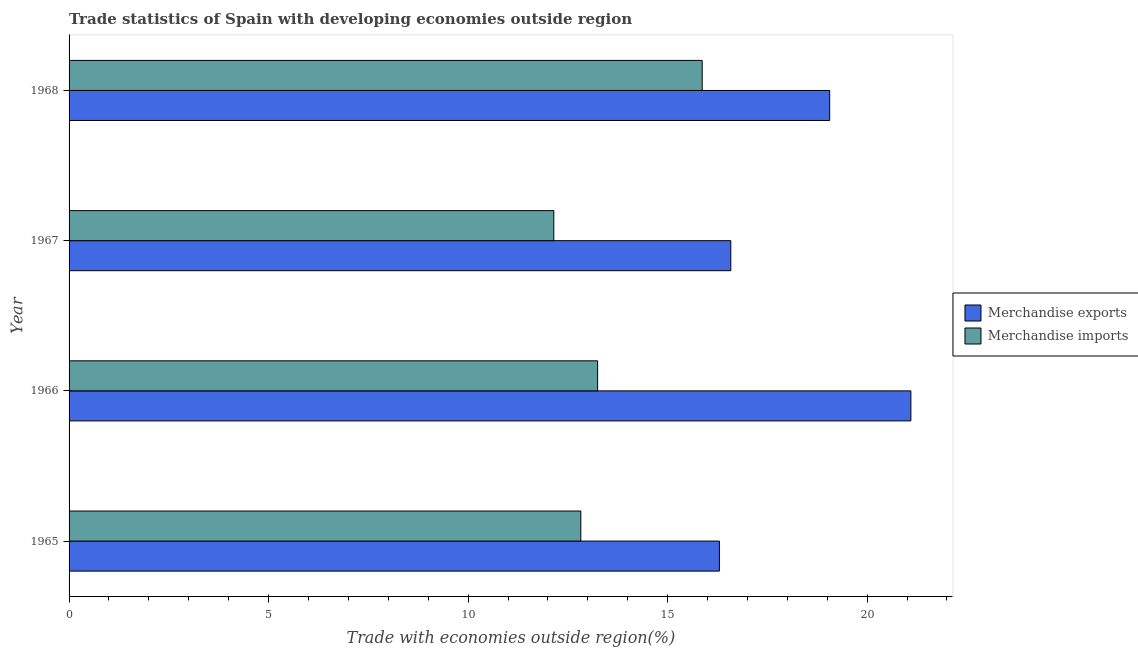How many different coloured bars are there?
Offer a very short reply. 2. How many groups of bars are there?
Give a very brief answer. 4. Are the number of bars per tick equal to the number of legend labels?
Your answer should be compact. Yes. What is the label of the 1st group of bars from the top?
Offer a terse response. 1968. What is the merchandise imports in 1967?
Provide a succinct answer. 12.15. Across all years, what is the maximum merchandise exports?
Your answer should be very brief. 21.09. Across all years, what is the minimum merchandise imports?
Give a very brief answer. 12.15. In which year was the merchandise imports maximum?
Offer a terse response. 1968. In which year was the merchandise exports minimum?
Your response must be concise. 1965. What is the total merchandise imports in the graph?
Offer a very short reply. 54.08. What is the difference between the merchandise imports in 1965 and that in 1967?
Offer a very short reply. 0.68. What is the difference between the merchandise exports in 1968 and the merchandise imports in 1965?
Provide a succinct answer. 6.24. What is the average merchandise imports per year?
Your answer should be compact. 13.52. In the year 1967, what is the difference between the merchandise imports and merchandise exports?
Your response must be concise. -4.43. What is the ratio of the merchandise imports in 1966 to that in 1967?
Provide a succinct answer. 1.09. Is the merchandise imports in 1966 less than that in 1967?
Offer a terse response. No. What is the difference between the highest and the second highest merchandise imports?
Keep it short and to the point. 2.62. What is the difference between the highest and the lowest merchandise exports?
Give a very brief answer. 4.8. In how many years, is the merchandise exports greater than the average merchandise exports taken over all years?
Your answer should be compact. 2. Is the sum of the merchandise imports in 1965 and 1966 greater than the maximum merchandise exports across all years?
Provide a short and direct response. Yes. How many bars are there?
Offer a terse response. 8. Are all the bars in the graph horizontal?
Provide a succinct answer. Yes. How many years are there in the graph?
Keep it short and to the point. 4. What is the difference between two consecutive major ticks on the X-axis?
Your answer should be compact. 5. Are the values on the major ticks of X-axis written in scientific E-notation?
Your answer should be very brief. No. Does the graph contain any zero values?
Offer a very short reply. No. Where does the legend appear in the graph?
Make the answer very short. Center right. How are the legend labels stacked?
Ensure brevity in your answer.  Vertical. What is the title of the graph?
Your response must be concise. Trade statistics of Spain with developing economies outside region. Does "Long-term debt" appear as one of the legend labels in the graph?
Your response must be concise. No. What is the label or title of the X-axis?
Provide a succinct answer. Trade with economies outside region(%). What is the label or title of the Y-axis?
Your answer should be compact. Year. What is the Trade with economies outside region(%) in Merchandise exports in 1965?
Offer a very short reply. 16.3. What is the Trade with economies outside region(%) of Merchandise imports in 1965?
Your answer should be very brief. 12.82. What is the Trade with economies outside region(%) in Merchandise exports in 1966?
Make the answer very short. 21.09. What is the Trade with economies outside region(%) of Merchandise imports in 1966?
Offer a very short reply. 13.25. What is the Trade with economies outside region(%) in Merchandise exports in 1967?
Make the answer very short. 16.58. What is the Trade with economies outside region(%) of Merchandise imports in 1967?
Your answer should be very brief. 12.15. What is the Trade with economies outside region(%) in Merchandise exports in 1968?
Your answer should be compact. 19.06. What is the Trade with economies outside region(%) in Merchandise imports in 1968?
Keep it short and to the point. 15.87. Across all years, what is the maximum Trade with economies outside region(%) of Merchandise exports?
Keep it short and to the point. 21.09. Across all years, what is the maximum Trade with economies outside region(%) of Merchandise imports?
Give a very brief answer. 15.87. Across all years, what is the minimum Trade with economies outside region(%) in Merchandise exports?
Your response must be concise. 16.3. Across all years, what is the minimum Trade with economies outside region(%) of Merchandise imports?
Ensure brevity in your answer.  12.15. What is the total Trade with economies outside region(%) in Merchandise exports in the graph?
Offer a very short reply. 73.04. What is the total Trade with economies outside region(%) in Merchandise imports in the graph?
Provide a short and direct response. 54.08. What is the difference between the Trade with economies outside region(%) in Merchandise exports in 1965 and that in 1966?
Offer a very short reply. -4.8. What is the difference between the Trade with economies outside region(%) in Merchandise imports in 1965 and that in 1966?
Ensure brevity in your answer.  -0.42. What is the difference between the Trade with economies outside region(%) in Merchandise exports in 1965 and that in 1967?
Your answer should be very brief. -0.28. What is the difference between the Trade with economies outside region(%) of Merchandise imports in 1965 and that in 1967?
Provide a succinct answer. 0.68. What is the difference between the Trade with economies outside region(%) of Merchandise exports in 1965 and that in 1968?
Your answer should be very brief. -2.76. What is the difference between the Trade with economies outside region(%) of Merchandise imports in 1965 and that in 1968?
Provide a short and direct response. -3.04. What is the difference between the Trade with economies outside region(%) in Merchandise exports in 1966 and that in 1967?
Your response must be concise. 4.51. What is the difference between the Trade with economies outside region(%) in Merchandise imports in 1966 and that in 1967?
Provide a succinct answer. 1.1. What is the difference between the Trade with economies outside region(%) of Merchandise exports in 1966 and that in 1968?
Provide a succinct answer. 2.03. What is the difference between the Trade with economies outside region(%) in Merchandise imports in 1966 and that in 1968?
Your answer should be compact. -2.62. What is the difference between the Trade with economies outside region(%) of Merchandise exports in 1967 and that in 1968?
Offer a very short reply. -2.48. What is the difference between the Trade with economies outside region(%) in Merchandise imports in 1967 and that in 1968?
Give a very brief answer. -3.72. What is the difference between the Trade with economies outside region(%) of Merchandise exports in 1965 and the Trade with economies outside region(%) of Merchandise imports in 1966?
Provide a succinct answer. 3.05. What is the difference between the Trade with economies outside region(%) of Merchandise exports in 1965 and the Trade with economies outside region(%) of Merchandise imports in 1967?
Provide a short and direct response. 4.15. What is the difference between the Trade with economies outside region(%) in Merchandise exports in 1965 and the Trade with economies outside region(%) in Merchandise imports in 1968?
Your response must be concise. 0.43. What is the difference between the Trade with economies outside region(%) of Merchandise exports in 1966 and the Trade with economies outside region(%) of Merchandise imports in 1967?
Your answer should be very brief. 8.95. What is the difference between the Trade with economies outside region(%) in Merchandise exports in 1966 and the Trade with economies outside region(%) in Merchandise imports in 1968?
Provide a short and direct response. 5.23. What is the difference between the Trade with economies outside region(%) of Merchandise exports in 1967 and the Trade with economies outside region(%) of Merchandise imports in 1968?
Provide a short and direct response. 0.72. What is the average Trade with economies outside region(%) in Merchandise exports per year?
Offer a terse response. 18.26. What is the average Trade with economies outside region(%) in Merchandise imports per year?
Make the answer very short. 13.52. In the year 1965, what is the difference between the Trade with economies outside region(%) of Merchandise exports and Trade with economies outside region(%) of Merchandise imports?
Offer a terse response. 3.47. In the year 1966, what is the difference between the Trade with economies outside region(%) of Merchandise exports and Trade with economies outside region(%) of Merchandise imports?
Offer a terse response. 7.85. In the year 1967, what is the difference between the Trade with economies outside region(%) of Merchandise exports and Trade with economies outside region(%) of Merchandise imports?
Provide a short and direct response. 4.44. In the year 1968, what is the difference between the Trade with economies outside region(%) of Merchandise exports and Trade with economies outside region(%) of Merchandise imports?
Ensure brevity in your answer.  3.19. What is the ratio of the Trade with economies outside region(%) in Merchandise exports in 1965 to that in 1966?
Your answer should be compact. 0.77. What is the ratio of the Trade with economies outside region(%) in Merchandise imports in 1965 to that in 1966?
Your answer should be very brief. 0.97. What is the ratio of the Trade with economies outside region(%) in Merchandise exports in 1965 to that in 1967?
Make the answer very short. 0.98. What is the ratio of the Trade with economies outside region(%) in Merchandise imports in 1965 to that in 1967?
Offer a very short reply. 1.06. What is the ratio of the Trade with economies outside region(%) of Merchandise exports in 1965 to that in 1968?
Your answer should be compact. 0.86. What is the ratio of the Trade with economies outside region(%) in Merchandise imports in 1965 to that in 1968?
Offer a very short reply. 0.81. What is the ratio of the Trade with economies outside region(%) in Merchandise exports in 1966 to that in 1967?
Ensure brevity in your answer.  1.27. What is the ratio of the Trade with economies outside region(%) of Merchandise imports in 1966 to that in 1967?
Offer a very short reply. 1.09. What is the ratio of the Trade with economies outside region(%) in Merchandise exports in 1966 to that in 1968?
Offer a very short reply. 1.11. What is the ratio of the Trade with economies outside region(%) in Merchandise imports in 1966 to that in 1968?
Offer a very short reply. 0.83. What is the ratio of the Trade with economies outside region(%) of Merchandise exports in 1967 to that in 1968?
Make the answer very short. 0.87. What is the ratio of the Trade with economies outside region(%) in Merchandise imports in 1967 to that in 1968?
Your answer should be very brief. 0.77. What is the difference between the highest and the second highest Trade with economies outside region(%) in Merchandise exports?
Provide a succinct answer. 2.03. What is the difference between the highest and the second highest Trade with economies outside region(%) in Merchandise imports?
Give a very brief answer. 2.62. What is the difference between the highest and the lowest Trade with economies outside region(%) of Merchandise exports?
Ensure brevity in your answer.  4.8. What is the difference between the highest and the lowest Trade with economies outside region(%) of Merchandise imports?
Provide a short and direct response. 3.72. 